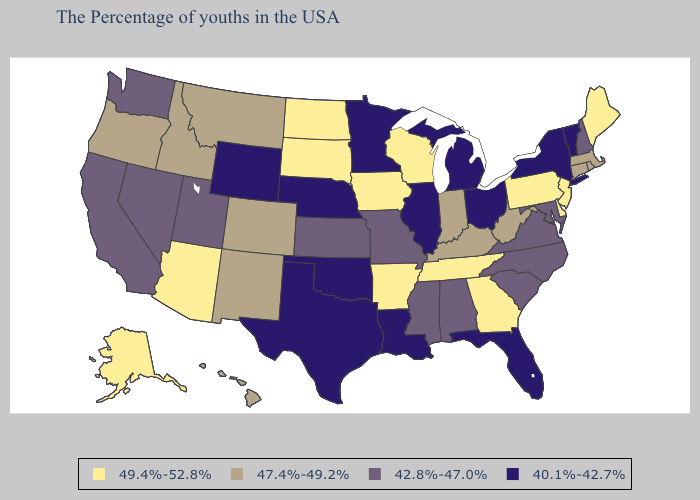What is the highest value in the Northeast ?
Concise answer only. 49.4%-52.8%. What is the highest value in states that border Iowa?
Quick response, please. 49.4%-52.8%. Does North Dakota have the same value as Michigan?
Answer briefly. No. Name the states that have a value in the range 49.4%-52.8%?
Keep it brief. Maine, New Jersey, Delaware, Pennsylvania, Georgia, Tennessee, Wisconsin, Arkansas, Iowa, South Dakota, North Dakota, Arizona, Alaska. Name the states that have a value in the range 42.8%-47.0%?
Quick response, please. New Hampshire, Maryland, Virginia, North Carolina, South Carolina, Alabama, Mississippi, Missouri, Kansas, Utah, Nevada, California, Washington. Does Missouri have a higher value than Alabama?
Answer briefly. No. What is the lowest value in the Northeast?
Keep it brief. 40.1%-42.7%. Which states hav the highest value in the South?
Keep it brief. Delaware, Georgia, Tennessee, Arkansas. Name the states that have a value in the range 40.1%-42.7%?
Short answer required. Vermont, New York, Ohio, Florida, Michigan, Illinois, Louisiana, Minnesota, Nebraska, Oklahoma, Texas, Wyoming. Among the states that border Missouri , which have the lowest value?
Short answer required. Illinois, Nebraska, Oklahoma. Does Oregon have a lower value than Arkansas?
Quick response, please. Yes. What is the value of Pennsylvania?
Quick response, please. 49.4%-52.8%. What is the lowest value in the Northeast?
Quick response, please. 40.1%-42.7%. Does the map have missing data?
Give a very brief answer. No. Among the states that border New Jersey , does Delaware have the highest value?
Concise answer only. Yes. 